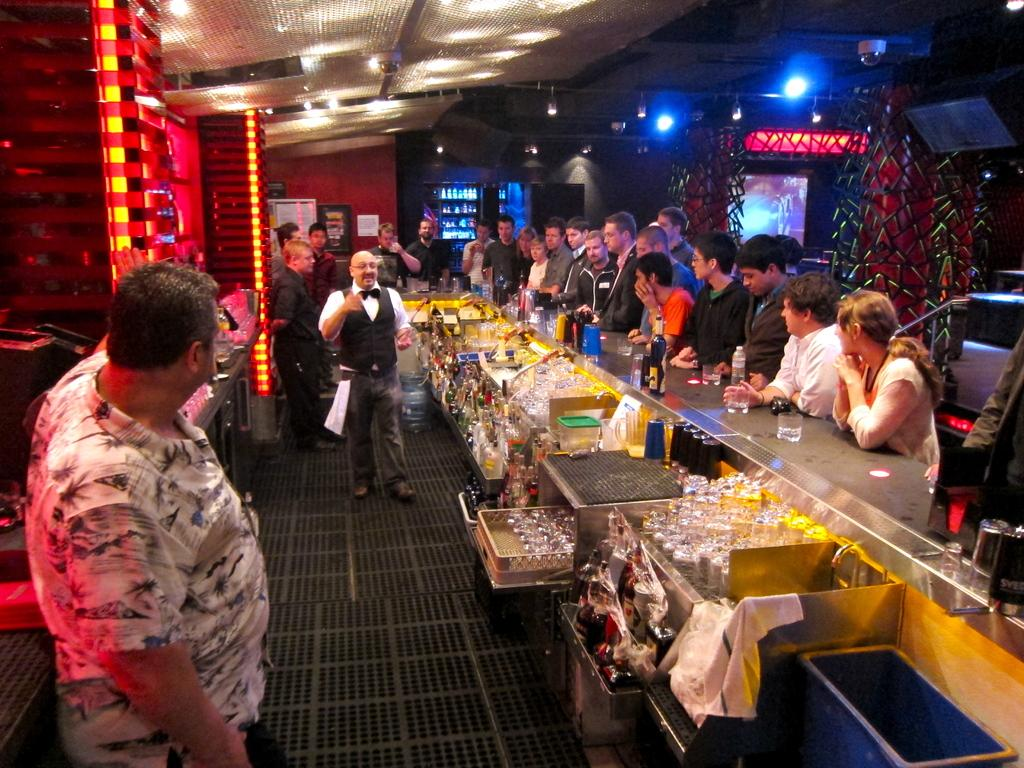What is the main subject of the image? There is a man standing in the middle of the image. Can you describe the man's clothing? The man is wearing a black coat. Are there any other people visible in the image? Yes, there are other people standing in the right side of the image. What type of setting is depicted in the image? The setting appears to be a bar. What credit card does the man use to pay for his drink in the image? There is no information about the man using a credit card or paying for a drink in the image. 